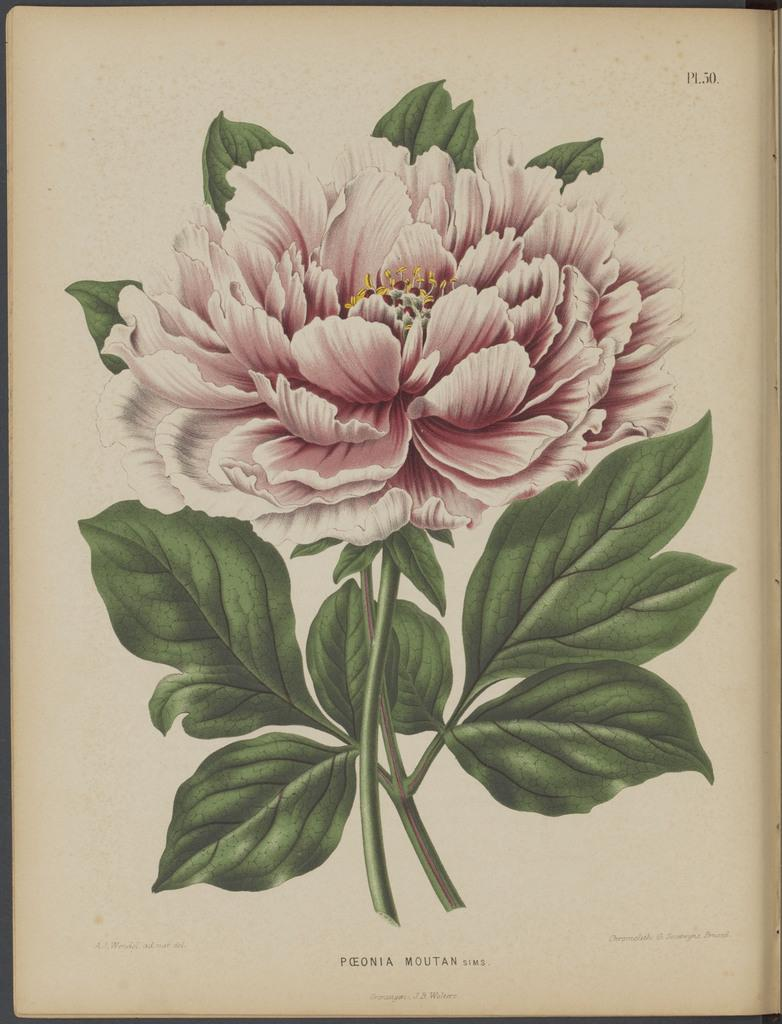What is depicted in the drawing in the image? There is a drawing of a flower in the image. What else is included in the drawing besides the flower? The drawing includes some leaves. Where is the drawing located in the image? The flower and leaves are in the middle of the image. What can be found at the bottom of the image? There is text written at the bottom of the image. What type of meat is being served in the image? There is no meat present in the image; it features a drawing of a flower with leaves and text at the bottom. What kind of juice is being poured into the glass in the image? There is no glass or juice present in the image. 